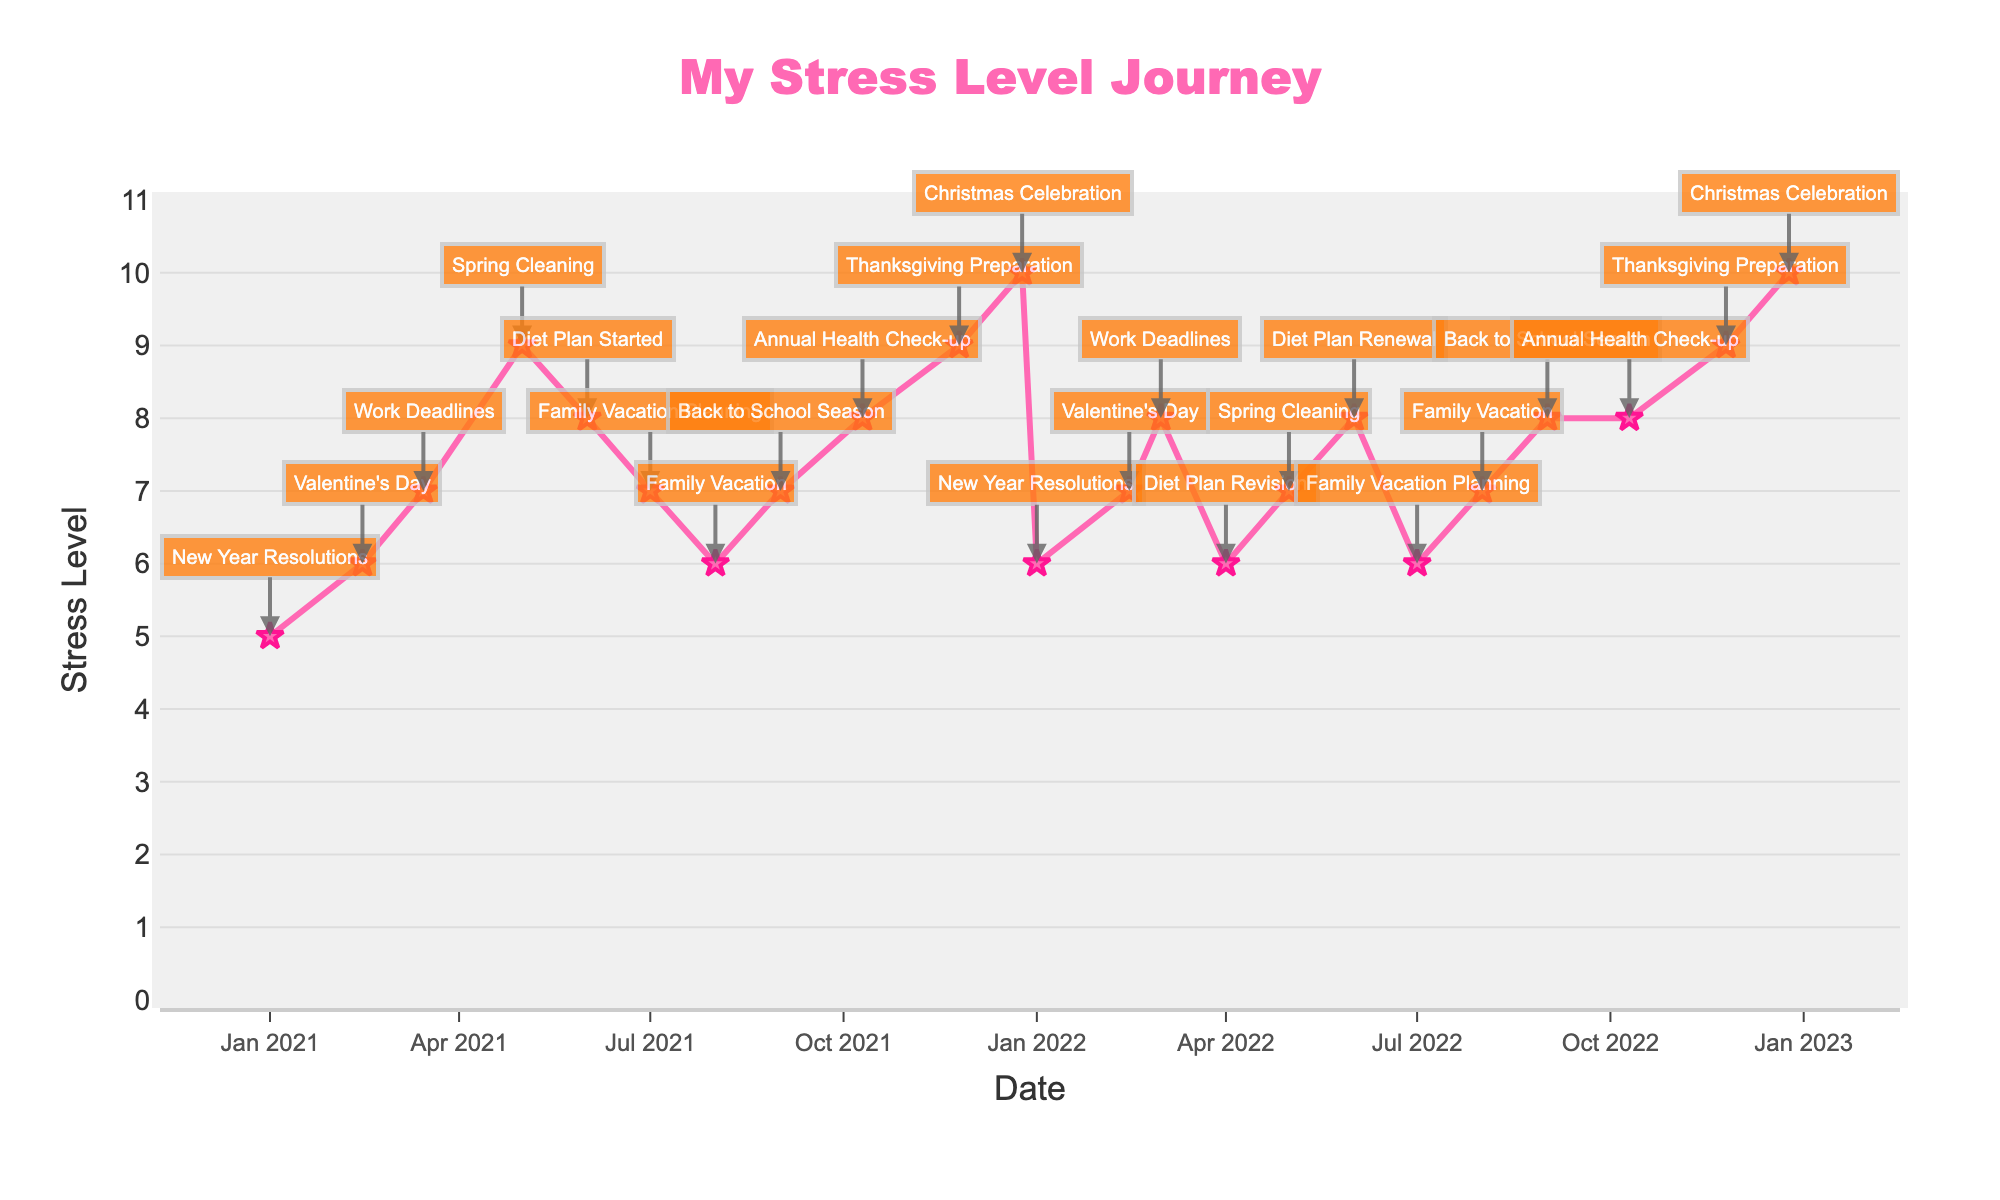What's the title of the plot? The title is prominently displayed at the top center of the plot.
Answer: My Stress Level Journey What is the stress level on Valentine's Day 2021? Locate the date February 14, 2021, on the x-axis and find the corresponding y-value on the stress level line.
Answer: 6 Which major life event correlates with the highest stress level recorded in 2022? Identify the highest y-value in 2022 and check the associated annotation.
Answer: Christmas Celebration What is the difference in stress level between New Year Resolutions in 2021 and 2022? Find the stress levels on January 1, 2021, and January 1, 2022, then subtract the smaller from the larger.
Answer: 5 - 6 = -1 How does the stress level during Thanksgiving Preparation in 2022 compare to the stress level during Thanksgiving Preparation in 2021? Locate both dates on the x-axis (November 25, 2021, and November 25, 2022) and compare the y-values.
Answer: Same (9) After which major life event in 2021 did the stress level start to decrease consistently until February 2022? Identify the event preceding the consistent decrease from August 2021 to February 2022.
Answer: Family Vacation What is the average stress level recorded in the months when "Diet Plan" events occurred in 2021? Note the stress levels for June 1 (8) and December 1 (8) in 2021, sum them up, and divide by the number of events.
Answer: (8 + 8) / 2 = 8 Which major life event directly correlates with a stress level of 7 on March 1, 2022? Find the date March 1, 2022, on the x-axis and read the annotation.
Answer: Work Deadlines How many major life events are recorded in this time series plot? Count the annotations on the plot.
Answer: 24 In which month of 2021 was the stress level the highest and what was the corresponding major life event? Identify the maximum y-value in 2021 and the associated date along with its annotation.
Answer: December (10, Christmas Celebration) 